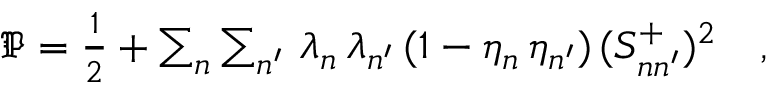Convert formula to latex. <formula><loc_0><loc_0><loc_500><loc_500>\begin{array} { r } { \mathfrak { P } = \frac { 1 } { 2 } + \sum _ { \mathfrak { n } } \sum _ { \mathfrak { n ^ { \prime } } } \, \lambda _ { \mathfrak { n } } \, \lambda _ { \mathfrak { n ^ { \prime } } } \, ( 1 - \eta _ { \mathfrak { n } } \, \eta _ { \mathfrak { n ^ { \prime } } } ) \, ( S _ { \mathfrak { n } \mathfrak { n ^ { \prime } } } ^ { + } ) ^ { 2 } \quad , } \end{array}</formula> 